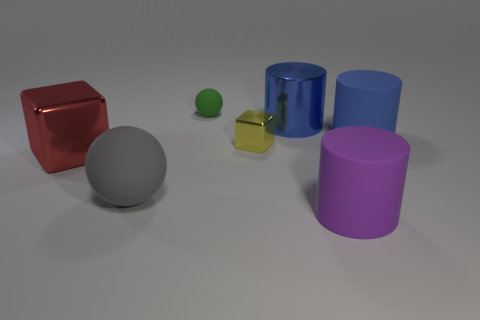Subtract all big matte cylinders. How many cylinders are left? 1 Add 2 cubes. How many objects exist? 9 Subtract 1 cylinders. How many cylinders are left? 2 Subtract all gray spheres. How many blue cylinders are left? 2 Subtract all purple cylinders. How many cylinders are left? 2 Subtract all blocks. How many objects are left? 5 Add 6 big blue metal cylinders. How many big blue metal cylinders exist? 7 Subtract 0 brown cubes. How many objects are left? 7 Subtract all cyan cubes. Subtract all purple spheres. How many cubes are left? 2 Subtract all tiny purple balls. Subtract all large gray objects. How many objects are left? 6 